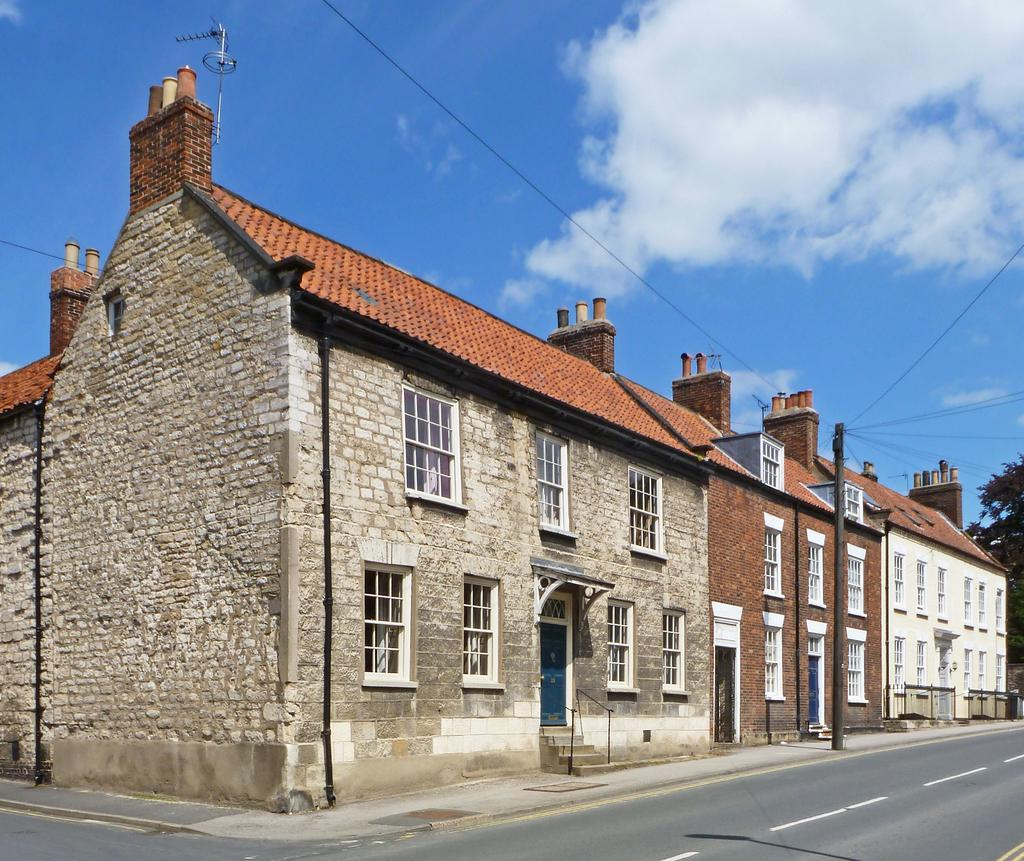What type of structures can be seen in the image? There are buildings in the image. What architectural features are visible on the buildings? There are windows, doors, and stairs visible on the buildings. What other objects can be seen in the image? There is a pole, wires, a road, and trees in the image. What is the color of the sky in the image? The sky is blue and white in color. What type of drain can be seen in the image? There is no drain present in the image. What subject is being taught in the image? There is no teaching or classroom scene depicted in the image. 